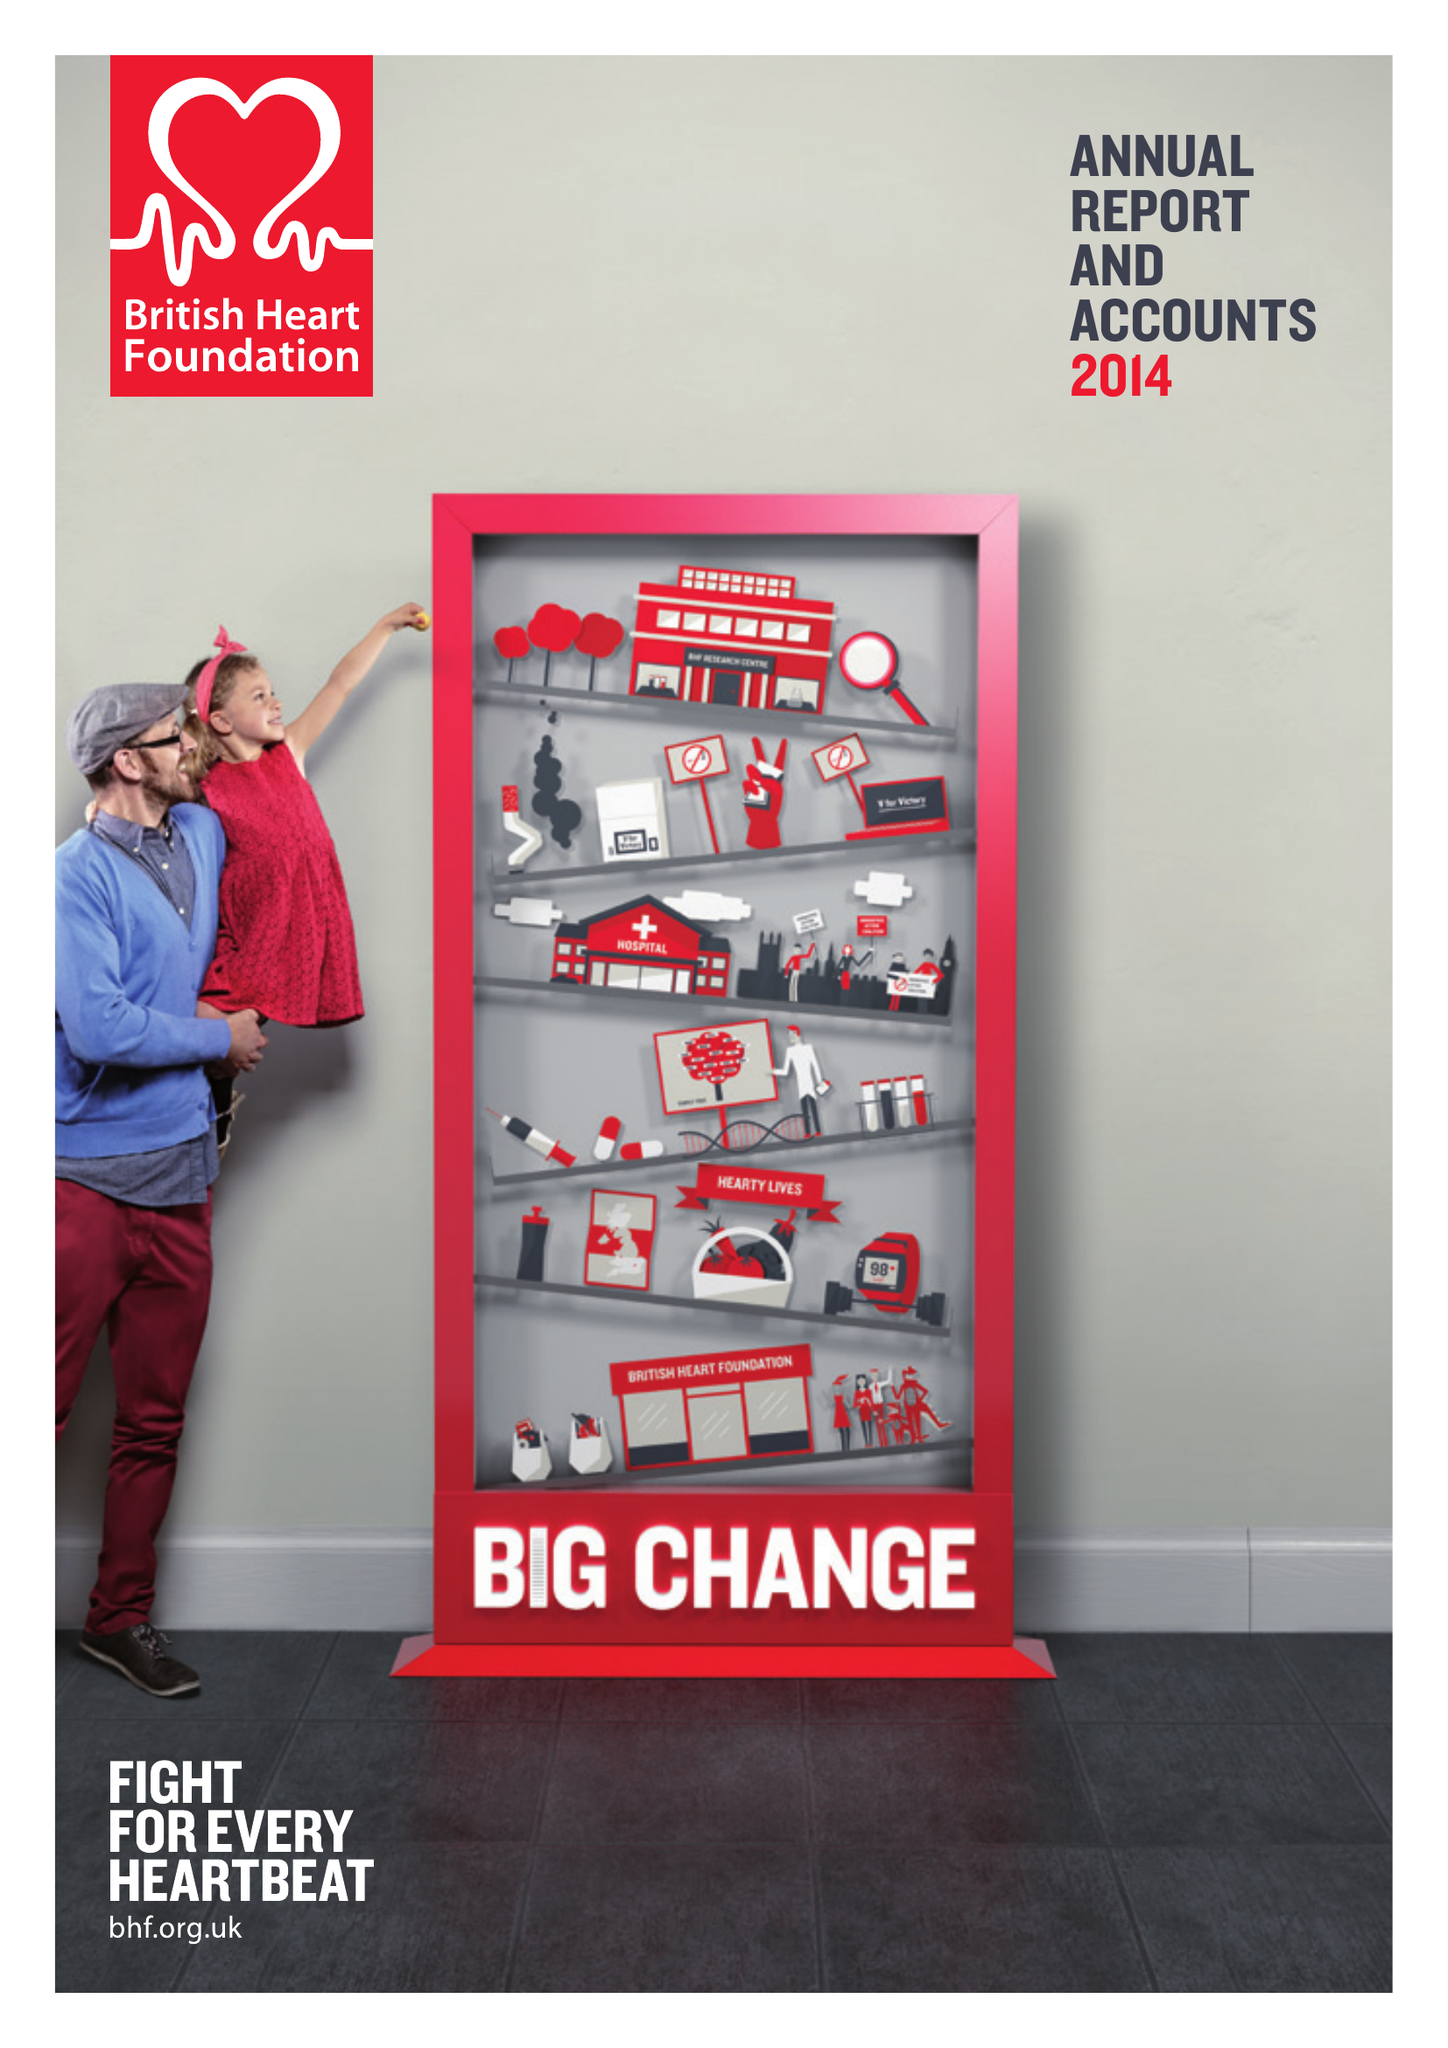What is the value for the income_annually_in_british_pounds?
Answer the question using a single word or phrase. 275100000.00 